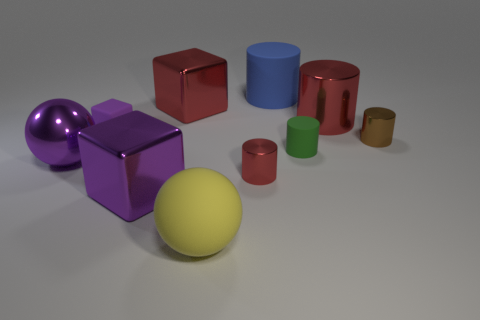There is a large cube that is the same color as the small matte cube; what is it made of?
Your response must be concise. Metal. The yellow ball has what size?
Make the answer very short. Large. There is a metal thing that is the same color as the large shiny ball; what is its shape?
Provide a succinct answer. Cube. How many cylinders are big metal objects or tiny rubber objects?
Provide a short and direct response. 2. Are there the same number of small red cylinders that are right of the brown cylinder and purple shiny spheres left of the large matte cylinder?
Keep it short and to the point. No. What size is the green object that is the same shape as the small brown metal object?
Keep it short and to the point. Small. What is the size of the rubber object that is both to the left of the big blue rubber thing and behind the yellow matte ball?
Offer a terse response. Small. There is a brown metallic cylinder; are there any large objects on the left side of it?
Offer a terse response. Yes. What number of things are red things left of the blue object or metallic cubes?
Offer a very short reply. 3. What number of tiny shiny things are left of the small shiny cylinder that is right of the blue matte cylinder?
Provide a succinct answer. 1. 